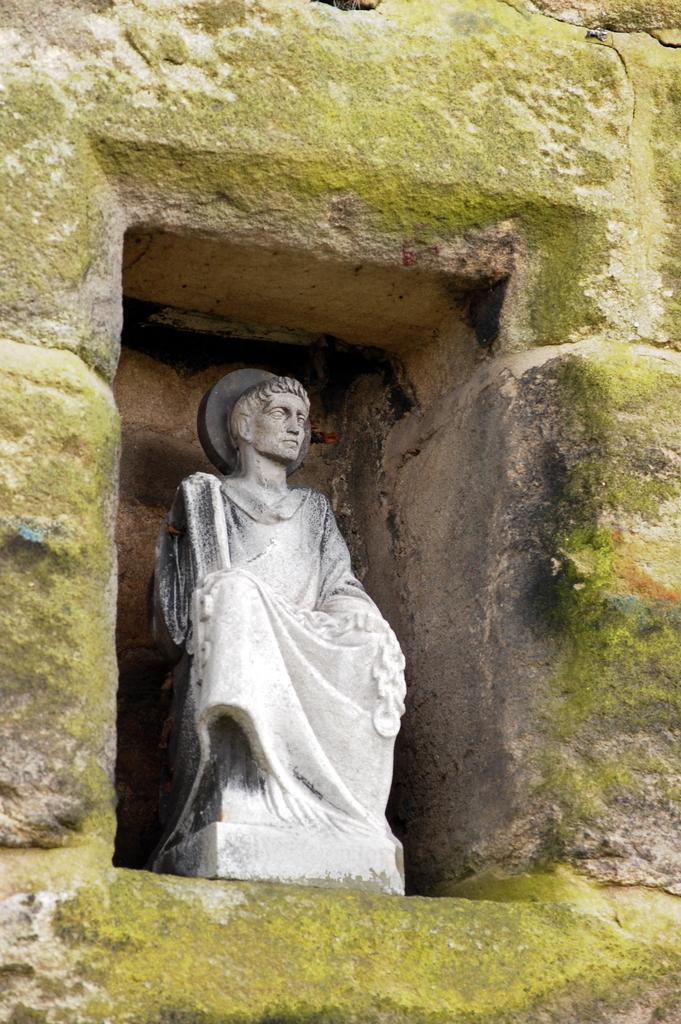What is the main subject of the image? There is a statue in the image. Where is the statue located? The statue is on a wall. What type of stove is visible in the image? There is no stove present in the image; it features a statue on a wall. How does the leaf contribute to the health of the statue in the image? There is no leaf or mention of health in the image; it only shows a statue on a wall. 